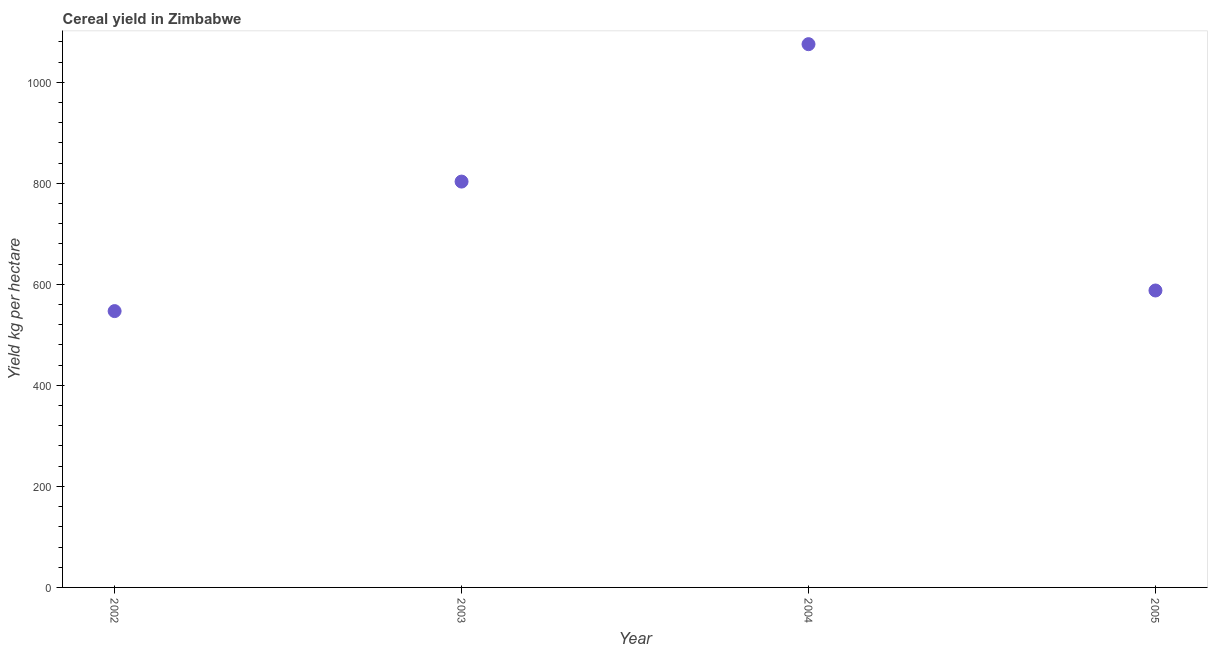What is the cereal yield in 2005?
Make the answer very short. 587.76. Across all years, what is the maximum cereal yield?
Your answer should be compact. 1075.34. Across all years, what is the minimum cereal yield?
Your answer should be compact. 546.97. In which year was the cereal yield maximum?
Make the answer very short. 2004. In which year was the cereal yield minimum?
Provide a short and direct response. 2002. What is the sum of the cereal yield?
Keep it short and to the point. 3013.42. What is the difference between the cereal yield in 2002 and 2003?
Your response must be concise. -256.38. What is the average cereal yield per year?
Your response must be concise. 753.35. What is the median cereal yield?
Your answer should be compact. 695.56. What is the ratio of the cereal yield in 2003 to that in 2004?
Ensure brevity in your answer.  0.75. What is the difference between the highest and the second highest cereal yield?
Keep it short and to the point. 271.99. Is the sum of the cereal yield in 2003 and 2004 greater than the maximum cereal yield across all years?
Your answer should be compact. Yes. What is the difference between the highest and the lowest cereal yield?
Give a very brief answer. 528.37. In how many years, is the cereal yield greater than the average cereal yield taken over all years?
Offer a terse response. 2. Does the cereal yield monotonically increase over the years?
Your response must be concise. No. How many dotlines are there?
Provide a succinct answer. 1. Does the graph contain any zero values?
Provide a short and direct response. No. Does the graph contain grids?
Your answer should be compact. No. What is the title of the graph?
Give a very brief answer. Cereal yield in Zimbabwe. What is the label or title of the X-axis?
Keep it short and to the point. Year. What is the label or title of the Y-axis?
Offer a terse response. Yield kg per hectare. What is the Yield kg per hectare in 2002?
Keep it short and to the point. 546.97. What is the Yield kg per hectare in 2003?
Offer a terse response. 803.35. What is the Yield kg per hectare in 2004?
Give a very brief answer. 1075.34. What is the Yield kg per hectare in 2005?
Keep it short and to the point. 587.76. What is the difference between the Yield kg per hectare in 2002 and 2003?
Your answer should be compact. -256.38. What is the difference between the Yield kg per hectare in 2002 and 2004?
Ensure brevity in your answer.  -528.37. What is the difference between the Yield kg per hectare in 2002 and 2005?
Give a very brief answer. -40.8. What is the difference between the Yield kg per hectare in 2003 and 2004?
Keep it short and to the point. -271.99. What is the difference between the Yield kg per hectare in 2003 and 2005?
Your answer should be very brief. 215.59. What is the difference between the Yield kg per hectare in 2004 and 2005?
Ensure brevity in your answer.  487.58. What is the ratio of the Yield kg per hectare in 2002 to that in 2003?
Offer a terse response. 0.68. What is the ratio of the Yield kg per hectare in 2002 to that in 2004?
Offer a terse response. 0.51. What is the ratio of the Yield kg per hectare in 2002 to that in 2005?
Offer a very short reply. 0.93. What is the ratio of the Yield kg per hectare in 2003 to that in 2004?
Offer a very short reply. 0.75. What is the ratio of the Yield kg per hectare in 2003 to that in 2005?
Provide a succinct answer. 1.37. What is the ratio of the Yield kg per hectare in 2004 to that in 2005?
Give a very brief answer. 1.83. 